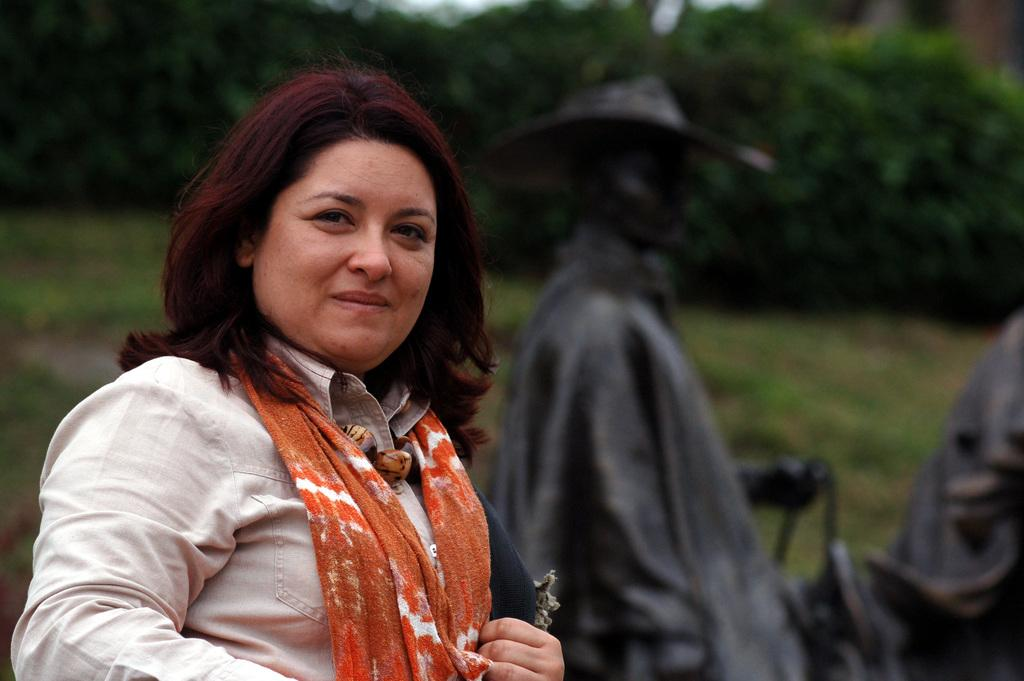Who is present in the image? There is a woman in the image. What is the woman wearing? The woman is wearing a white shirt. What expression does the woman has the woman in the image? The woman is smiling. What is the woman's posture in the image? The woman is standing. What can be seen in the background of the image? There are two statues near grass on the ground and trees on a hill in the background of the image. What time of day is it in the image, considering the morning light? The provided facts do not mention any specific time of day or lighting conditions, so it cannot be determined from the image. 